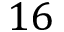Convert formula to latex. <formula><loc_0><loc_0><loc_500><loc_500>1 6</formula> 